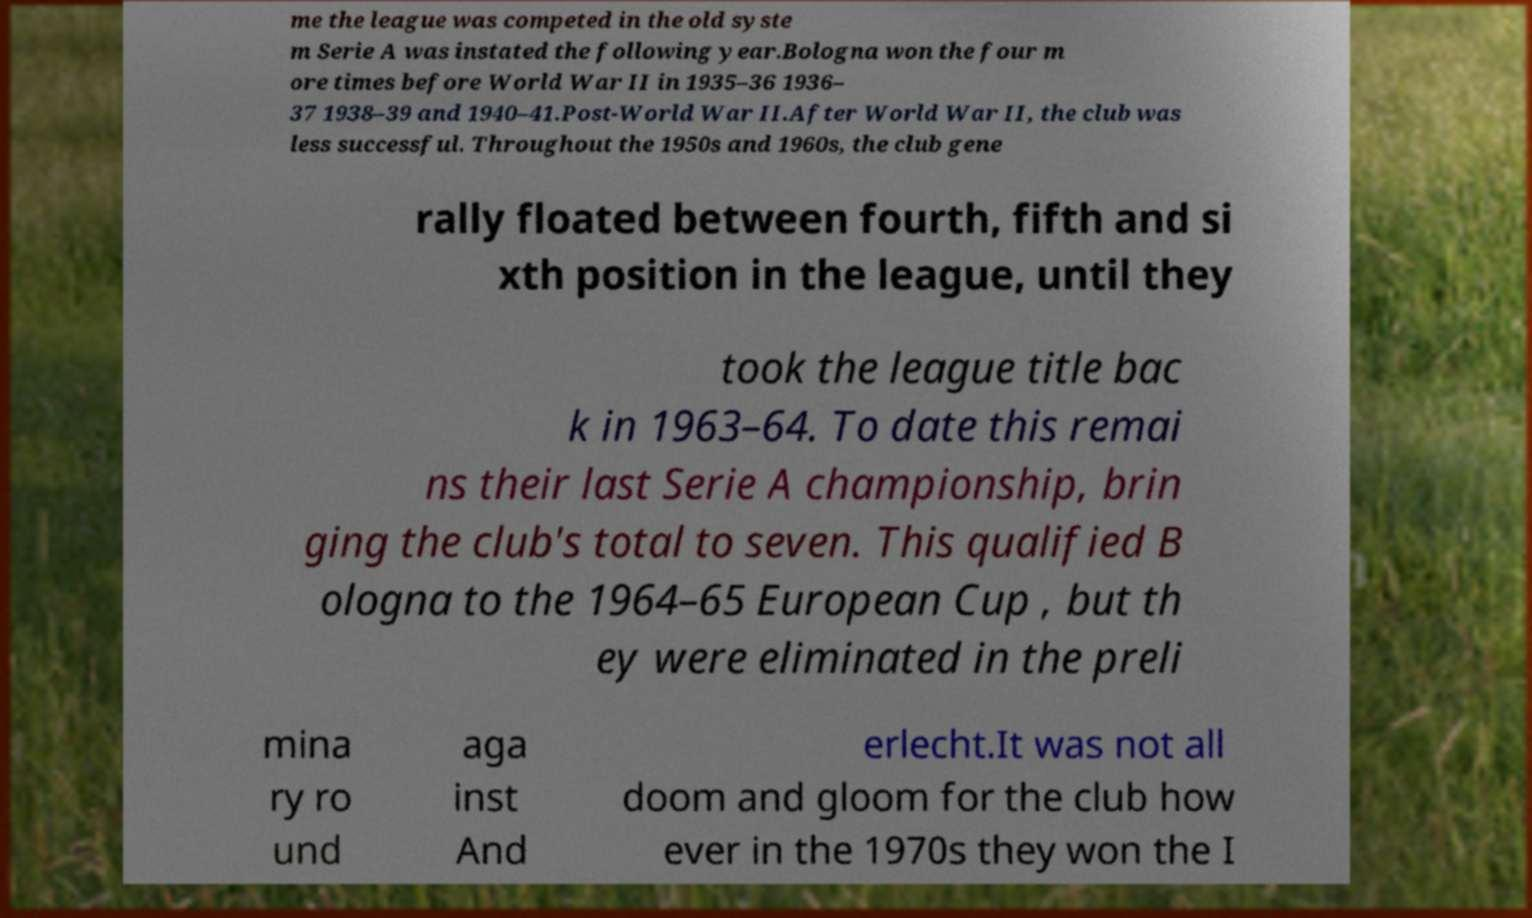I need the written content from this picture converted into text. Can you do that? me the league was competed in the old syste m Serie A was instated the following year.Bologna won the four m ore times before World War II in 1935–36 1936– 37 1938–39 and 1940–41.Post-World War II.After World War II, the club was less successful. Throughout the 1950s and 1960s, the club gene rally floated between fourth, fifth and si xth position in the league, until they took the league title bac k in 1963–64. To date this remai ns their last Serie A championship, brin ging the club's total to seven. This qualified B ologna to the 1964–65 European Cup , but th ey were eliminated in the preli mina ry ro und aga inst And erlecht.It was not all doom and gloom for the club how ever in the 1970s they won the I 